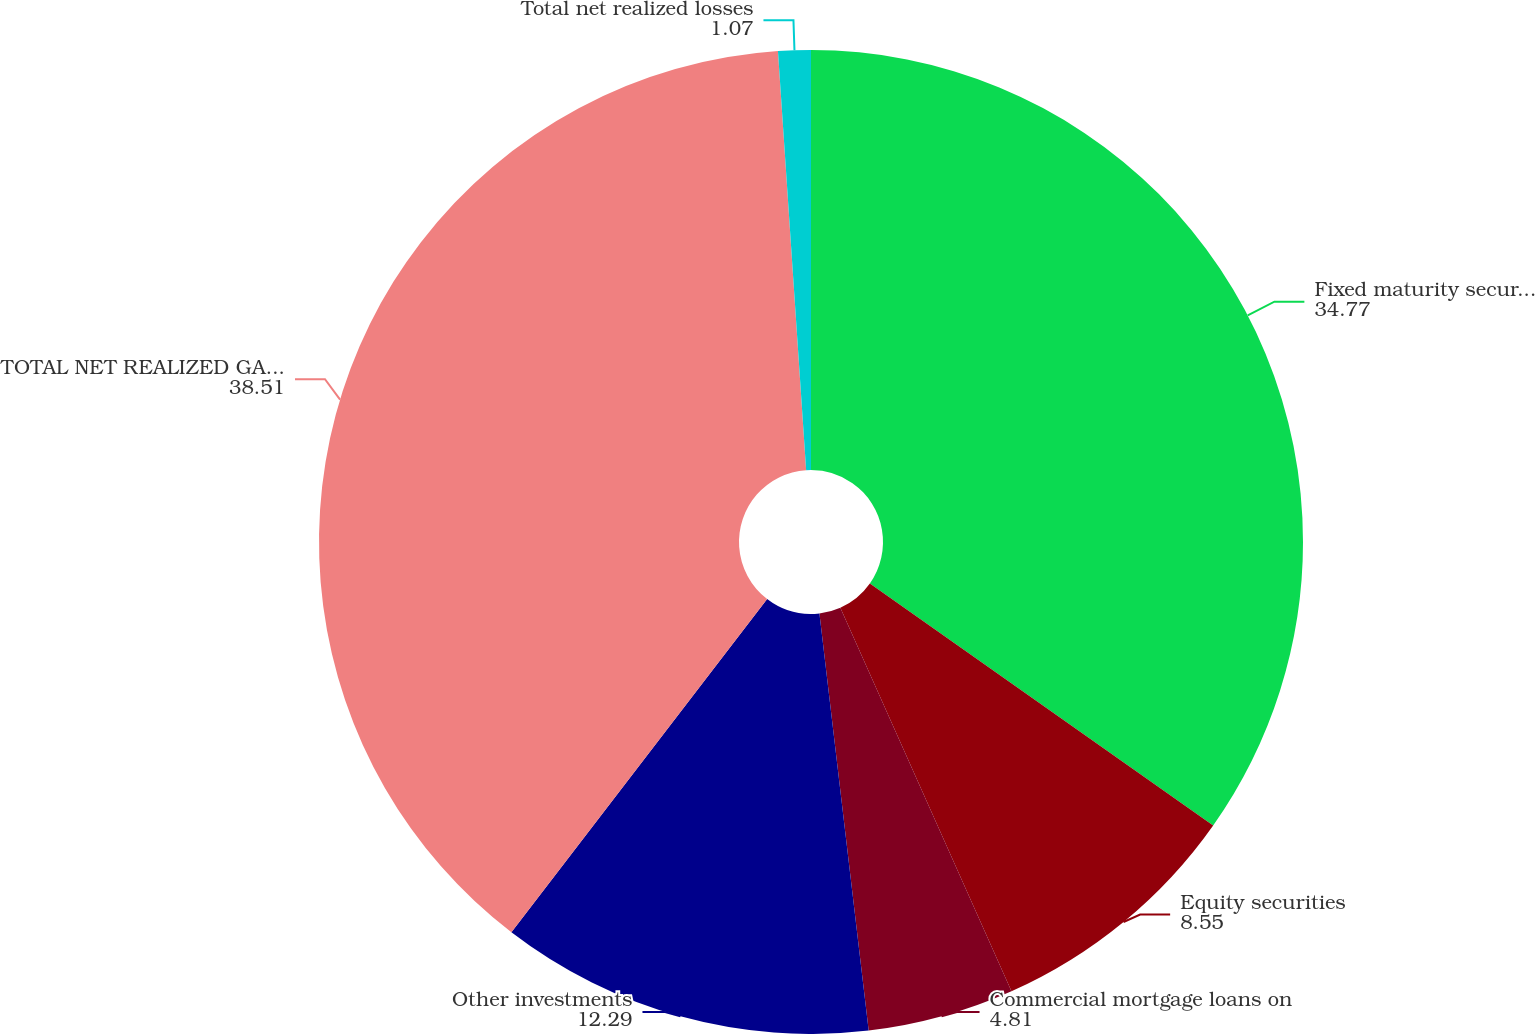<chart> <loc_0><loc_0><loc_500><loc_500><pie_chart><fcel>Fixed maturity securities<fcel>Equity securities<fcel>Commercial mortgage loans on<fcel>Other investments<fcel>TOTAL NET REALIZED GAINS<fcel>Total net realized losses<nl><fcel>34.77%<fcel>8.55%<fcel>4.81%<fcel>12.29%<fcel>38.51%<fcel>1.07%<nl></chart> 